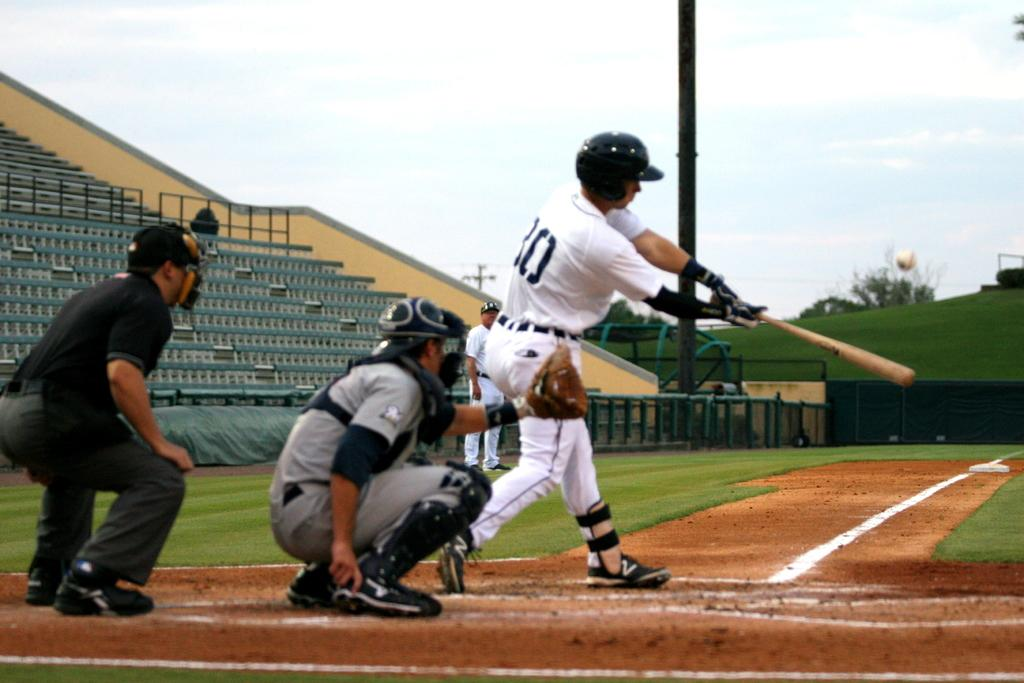<image>
Describe the image concisely. a baseball pitcher wearing a shirt with a number 30 on it. 